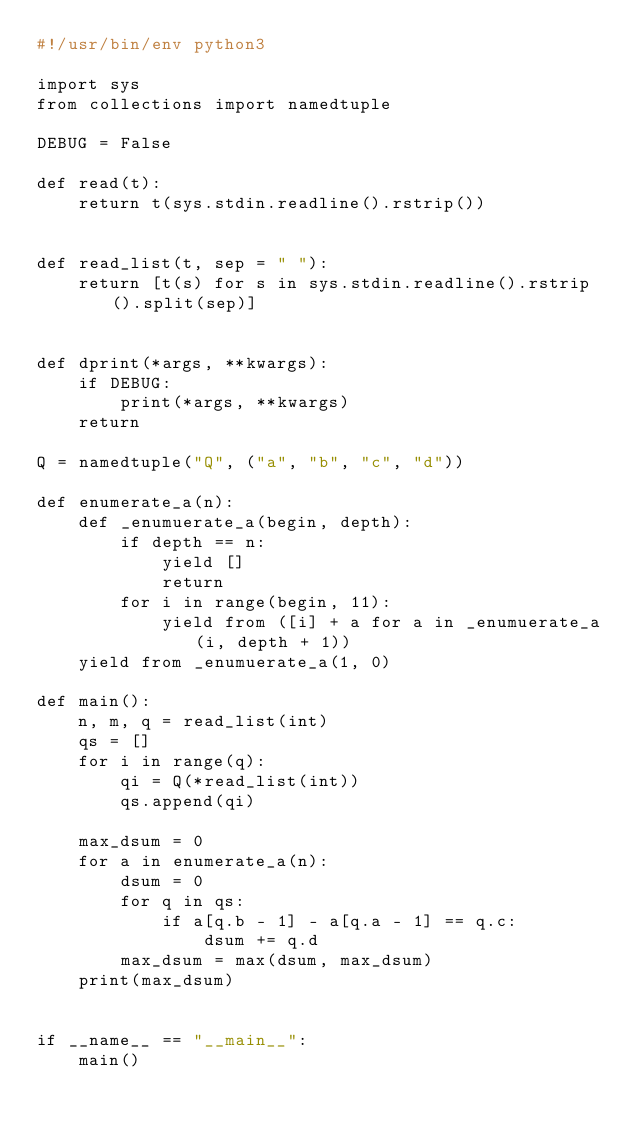<code> <loc_0><loc_0><loc_500><loc_500><_Python_>#!/usr/bin/env python3

import sys
from collections import namedtuple

DEBUG = False

def read(t):
    return t(sys.stdin.readline().rstrip())


def read_list(t, sep = " "):
    return [t(s) for s in sys.stdin.readline().rstrip().split(sep)]


def dprint(*args, **kwargs):
    if DEBUG:
        print(*args, **kwargs)
    return

Q = namedtuple("Q", ("a", "b", "c", "d"))

def enumerate_a(n):
    def _enumuerate_a(begin, depth):
        if depth == n:
            yield []
            return
        for i in range(begin, 11):
            yield from ([i] + a for a in _enumuerate_a(i, depth + 1))
    yield from _enumuerate_a(1, 0)

def main():
    n, m, q = read_list(int)
    qs = []
    for i in range(q):
        qi = Q(*read_list(int))
        qs.append(qi)
    
    max_dsum = 0
    for a in enumerate_a(n):
        dsum = 0
        for q in qs:
            if a[q.b - 1] - a[q.a - 1] == q.c:
                dsum += q.d
        max_dsum = max(dsum, max_dsum)
    print(max_dsum)


if __name__ == "__main__":
    main()
</code> 